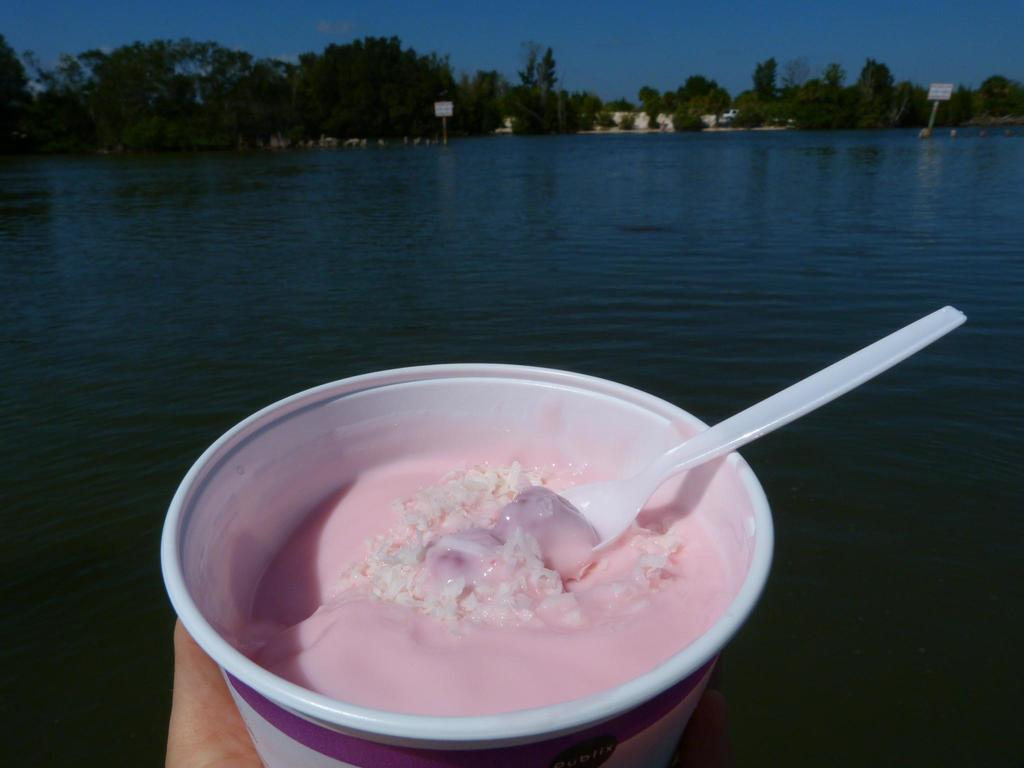What type of natural body of water is visible in the image? There is a sea in the image. What type of vegetation is near the sea in the image? There are trees near the sea in the image. What is in the cup that is visible in the image? There is a cup with food content in the image. What utensil is associated with the cup in the image? There is a spoon associated with the cup in the image. What type of test is being conducted on the yam in the image? There is no yam present in the image, and therefore no test is being conducted. What type of shock can be seen affecting the trees in the image? There is no shock affecting the trees in the image; they appear to be standing normally. 